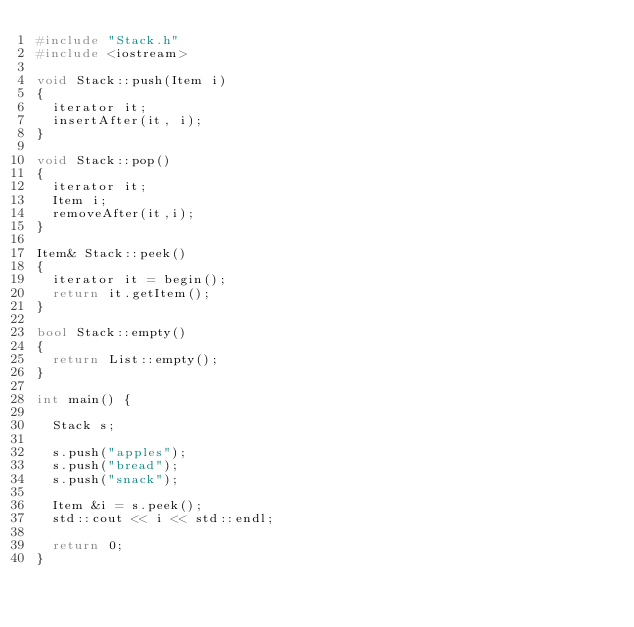<code> <loc_0><loc_0><loc_500><loc_500><_C++_>#include "Stack.h"
#include <iostream>

void Stack::push(Item i)
{
  iterator it;
  insertAfter(it, i);
}

void Stack::pop()
{
  iterator it;
  Item i;
  removeAfter(it,i);
}

Item& Stack::peek()
{
  iterator it = begin();
  return it.getItem();
}

bool Stack::empty()
{
  return List::empty();
}

int main() {

  Stack s;

  s.push("apples");
  s.push("bread");
  s.push("snack");

  Item &i = s.peek();
  std::cout << i << std::endl;
  
  return 0;
}
</code> 